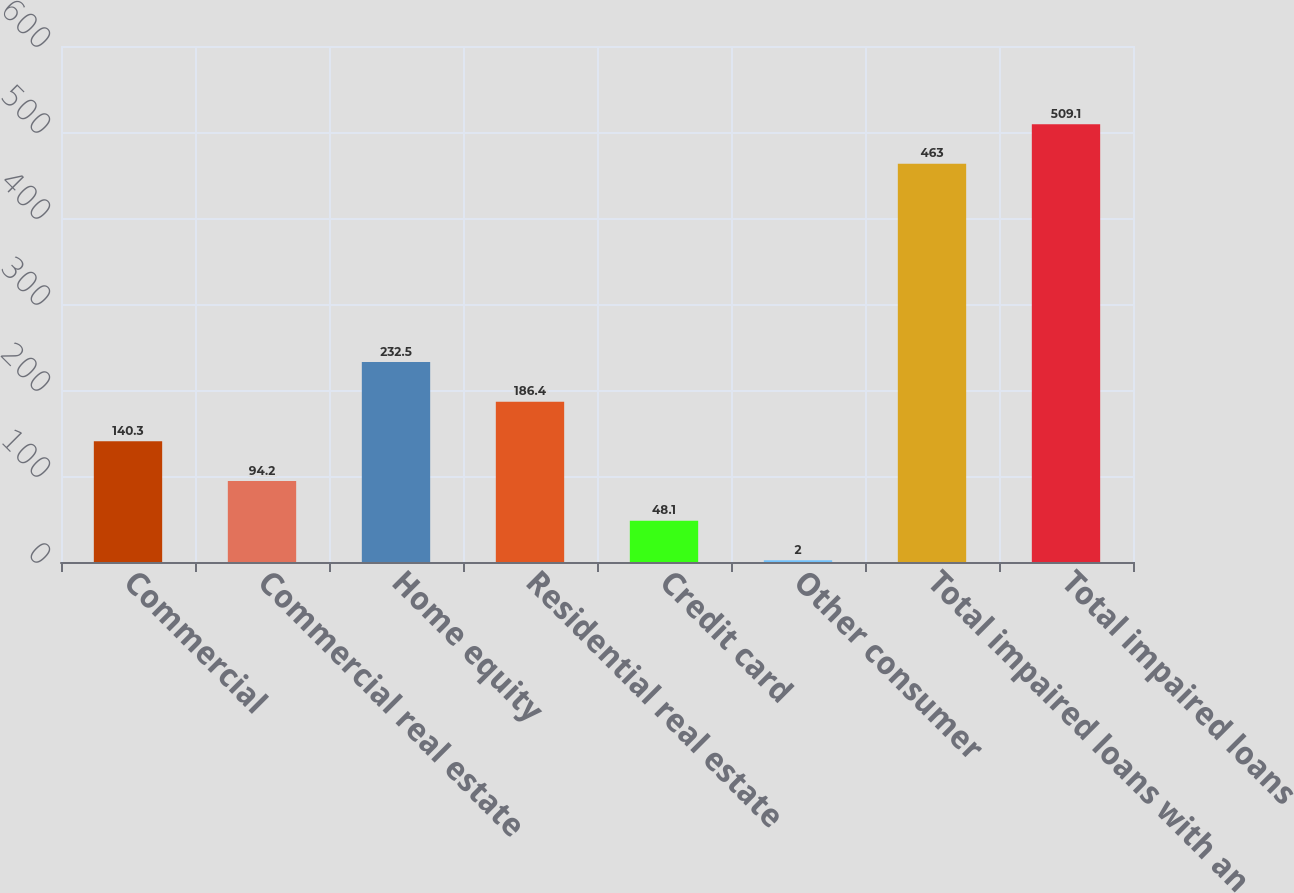Convert chart. <chart><loc_0><loc_0><loc_500><loc_500><bar_chart><fcel>Commercial<fcel>Commercial real estate<fcel>Home equity<fcel>Residential real estate<fcel>Credit card<fcel>Other consumer<fcel>Total impaired loans with an<fcel>Total impaired loans<nl><fcel>140.3<fcel>94.2<fcel>232.5<fcel>186.4<fcel>48.1<fcel>2<fcel>463<fcel>509.1<nl></chart> 